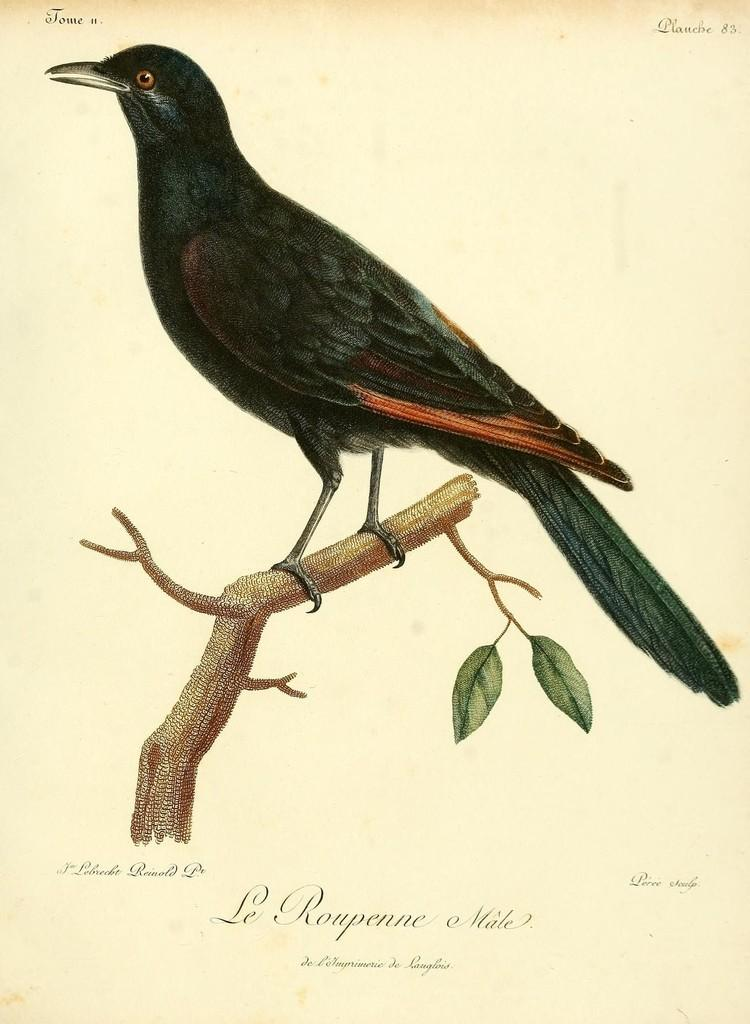What type of animal can be seen in the image? There is a bird in the image. Where is the bird located? The bird is on a tree. What is the condition of the tree in the image? The tree has leaves. What else is present in the image besides the bird and tree? There is text on a paper in the image. What type of cracker is the bird holding in its beak in the image? There is no cracker present in the image; the bird is on a tree with leaves. 